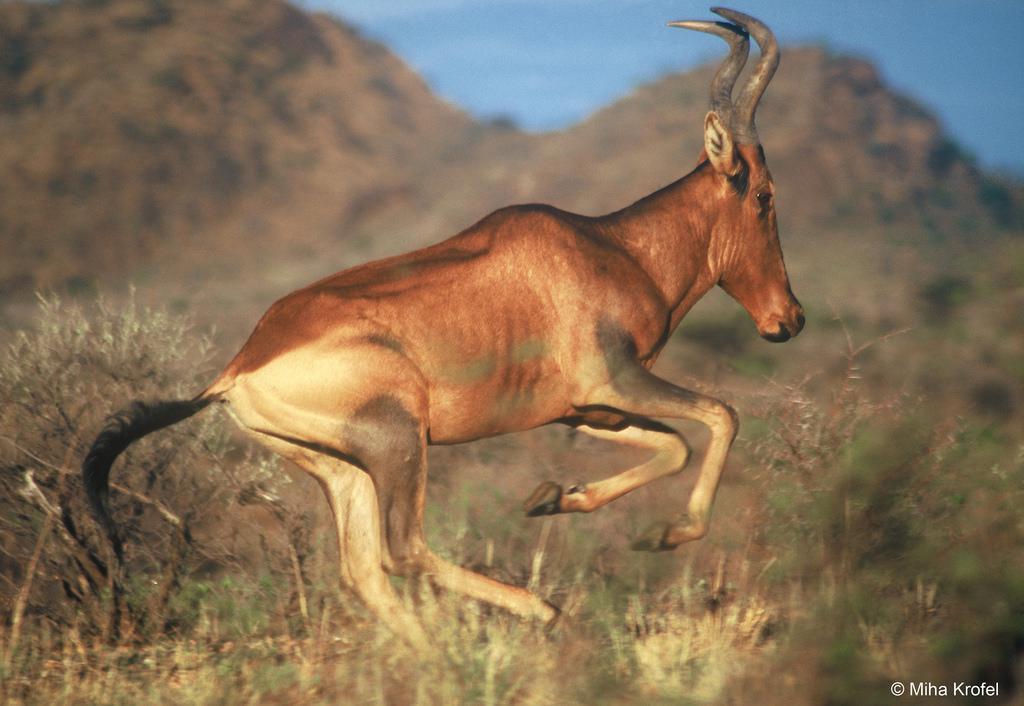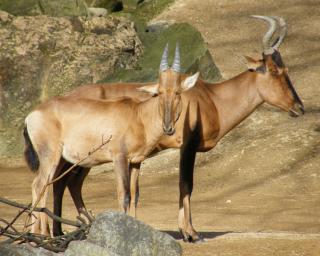The first image is the image on the left, the second image is the image on the right. Evaluate the accuracy of this statement regarding the images: "The left image shows an animal facing to the right.". Is it true? Answer yes or no. Yes. The first image is the image on the left, the second image is the image on the right. Examine the images to the left and right. Is the description "The left and right image contains the same number of antelopes." accurate? Answer yes or no. No. 